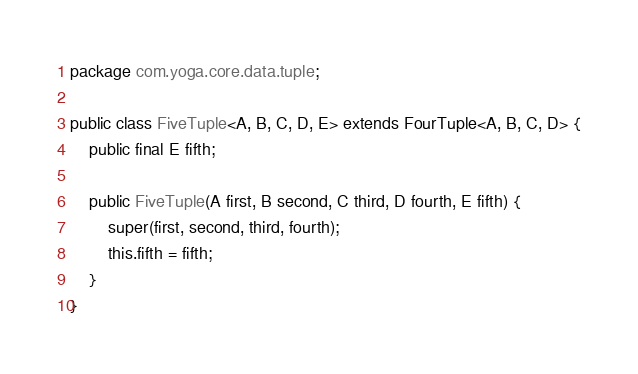Convert code to text. <code><loc_0><loc_0><loc_500><loc_500><_Java_>package com.yoga.core.data.tuple;

public class FiveTuple<A, B, C, D, E> extends FourTuple<A, B, C, D> {
    public final E fifth;

    public FiveTuple(A first, B second, C third, D fourth, E fifth) {
        super(first, second, third, fourth);
        this.fifth = fifth;
    }
}
</code> 